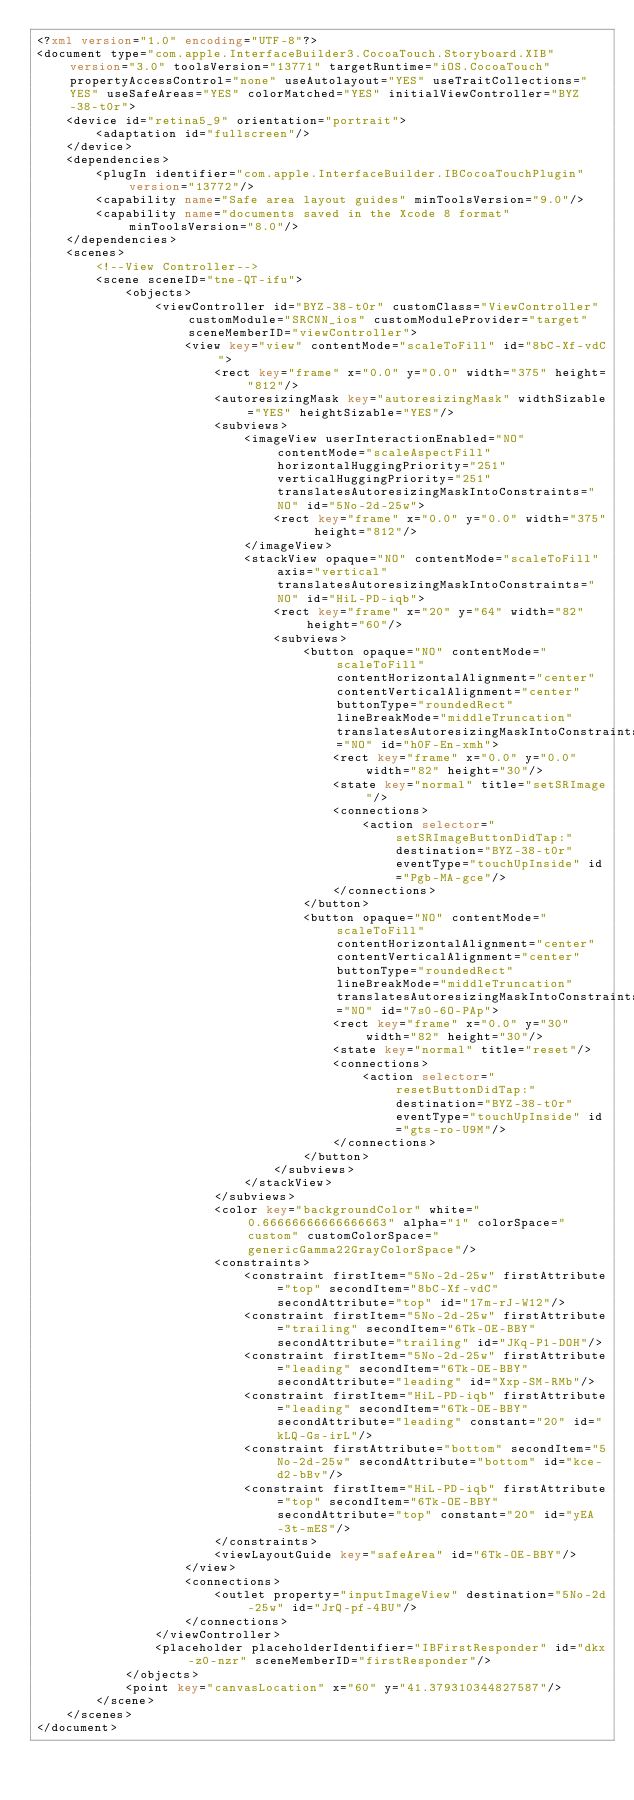<code> <loc_0><loc_0><loc_500><loc_500><_XML_><?xml version="1.0" encoding="UTF-8"?>
<document type="com.apple.InterfaceBuilder3.CocoaTouch.Storyboard.XIB" version="3.0" toolsVersion="13771" targetRuntime="iOS.CocoaTouch" propertyAccessControl="none" useAutolayout="YES" useTraitCollections="YES" useSafeAreas="YES" colorMatched="YES" initialViewController="BYZ-38-t0r">
    <device id="retina5_9" orientation="portrait">
        <adaptation id="fullscreen"/>
    </device>
    <dependencies>
        <plugIn identifier="com.apple.InterfaceBuilder.IBCocoaTouchPlugin" version="13772"/>
        <capability name="Safe area layout guides" minToolsVersion="9.0"/>
        <capability name="documents saved in the Xcode 8 format" minToolsVersion="8.0"/>
    </dependencies>
    <scenes>
        <!--View Controller-->
        <scene sceneID="tne-QT-ifu">
            <objects>
                <viewController id="BYZ-38-t0r" customClass="ViewController" customModule="SRCNN_ios" customModuleProvider="target" sceneMemberID="viewController">
                    <view key="view" contentMode="scaleToFill" id="8bC-Xf-vdC">
                        <rect key="frame" x="0.0" y="0.0" width="375" height="812"/>
                        <autoresizingMask key="autoresizingMask" widthSizable="YES" heightSizable="YES"/>
                        <subviews>
                            <imageView userInteractionEnabled="NO" contentMode="scaleAspectFill" horizontalHuggingPriority="251" verticalHuggingPriority="251" translatesAutoresizingMaskIntoConstraints="NO" id="5No-2d-25w">
                                <rect key="frame" x="0.0" y="0.0" width="375" height="812"/>
                            </imageView>
                            <stackView opaque="NO" contentMode="scaleToFill" axis="vertical" translatesAutoresizingMaskIntoConstraints="NO" id="HiL-PD-iqb">
                                <rect key="frame" x="20" y="64" width="82" height="60"/>
                                <subviews>
                                    <button opaque="NO" contentMode="scaleToFill" contentHorizontalAlignment="center" contentVerticalAlignment="center" buttonType="roundedRect" lineBreakMode="middleTruncation" translatesAutoresizingMaskIntoConstraints="NO" id="h0F-En-xmh">
                                        <rect key="frame" x="0.0" y="0.0" width="82" height="30"/>
                                        <state key="normal" title="setSRImage"/>
                                        <connections>
                                            <action selector="setSRImageButtonDidTap:" destination="BYZ-38-t0r" eventType="touchUpInside" id="Pgb-MA-gce"/>
                                        </connections>
                                    </button>
                                    <button opaque="NO" contentMode="scaleToFill" contentHorizontalAlignment="center" contentVerticalAlignment="center" buttonType="roundedRect" lineBreakMode="middleTruncation" translatesAutoresizingMaskIntoConstraints="NO" id="7s0-6O-PAp">
                                        <rect key="frame" x="0.0" y="30" width="82" height="30"/>
                                        <state key="normal" title="reset"/>
                                        <connections>
                                            <action selector="resetButtonDidTap:" destination="BYZ-38-t0r" eventType="touchUpInside" id="gts-ro-U9M"/>
                                        </connections>
                                    </button>
                                </subviews>
                            </stackView>
                        </subviews>
                        <color key="backgroundColor" white="0.66666666666666663" alpha="1" colorSpace="custom" customColorSpace="genericGamma22GrayColorSpace"/>
                        <constraints>
                            <constraint firstItem="5No-2d-25w" firstAttribute="top" secondItem="8bC-Xf-vdC" secondAttribute="top" id="17m-rJ-W12"/>
                            <constraint firstItem="5No-2d-25w" firstAttribute="trailing" secondItem="6Tk-OE-BBY" secondAttribute="trailing" id="JKq-P1-DOH"/>
                            <constraint firstItem="5No-2d-25w" firstAttribute="leading" secondItem="6Tk-OE-BBY" secondAttribute="leading" id="Xxp-SM-RMb"/>
                            <constraint firstItem="HiL-PD-iqb" firstAttribute="leading" secondItem="6Tk-OE-BBY" secondAttribute="leading" constant="20" id="kLQ-Gs-irL"/>
                            <constraint firstAttribute="bottom" secondItem="5No-2d-25w" secondAttribute="bottom" id="kce-d2-bBv"/>
                            <constraint firstItem="HiL-PD-iqb" firstAttribute="top" secondItem="6Tk-OE-BBY" secondAttribute="top" constant="20" id="yEA-3t-mES"/>
                        </constraints>
                        <viewLayoutGuide key="safeArea" id="6Tk-OE-BBY"/>
                    </view>
                    <connections>
                        <outlet property="inputImageView" destination="5No-2d-25w" id="JrQ-pf-4BU"/>
                    </connections>
                </viewController>
                <placeholder placeholderIdentifier="IBFirstResponder" id="dkx-z0-nzr" sceneMemberID="firstResponder"/>
            </objects>
            <point key="canvasLocation" x="60" y="41.379310344827587"/>
        </scene>
    </scenes>
</document>
</code> 